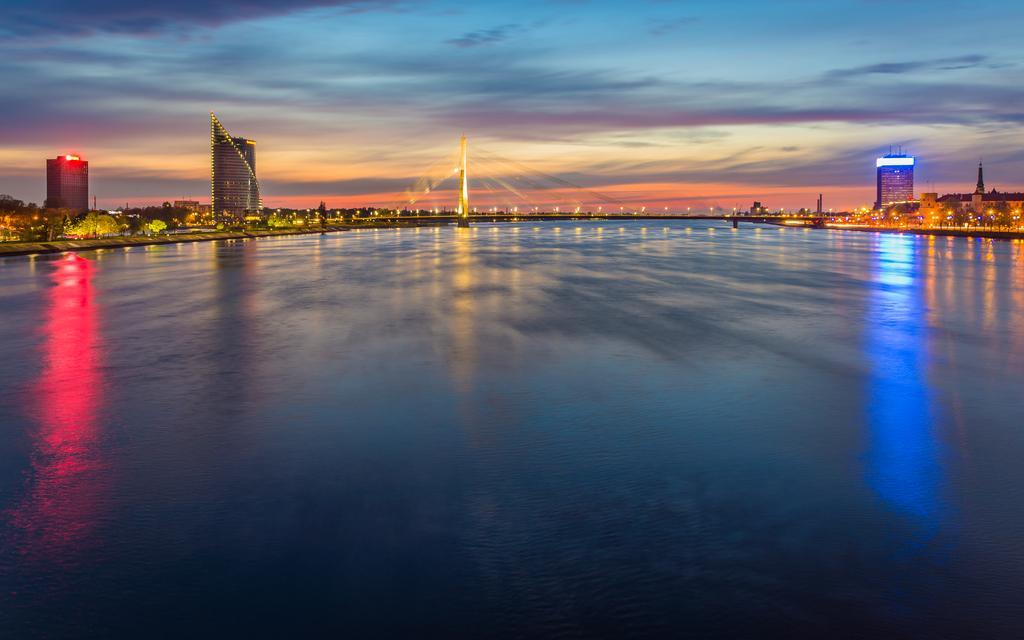Please provide a concise description of this image. At the bottom of the image there is water. In the background there is a bridge. And in the background there are trees and buildings with lights. At the top of the image there is sky with clouds. 